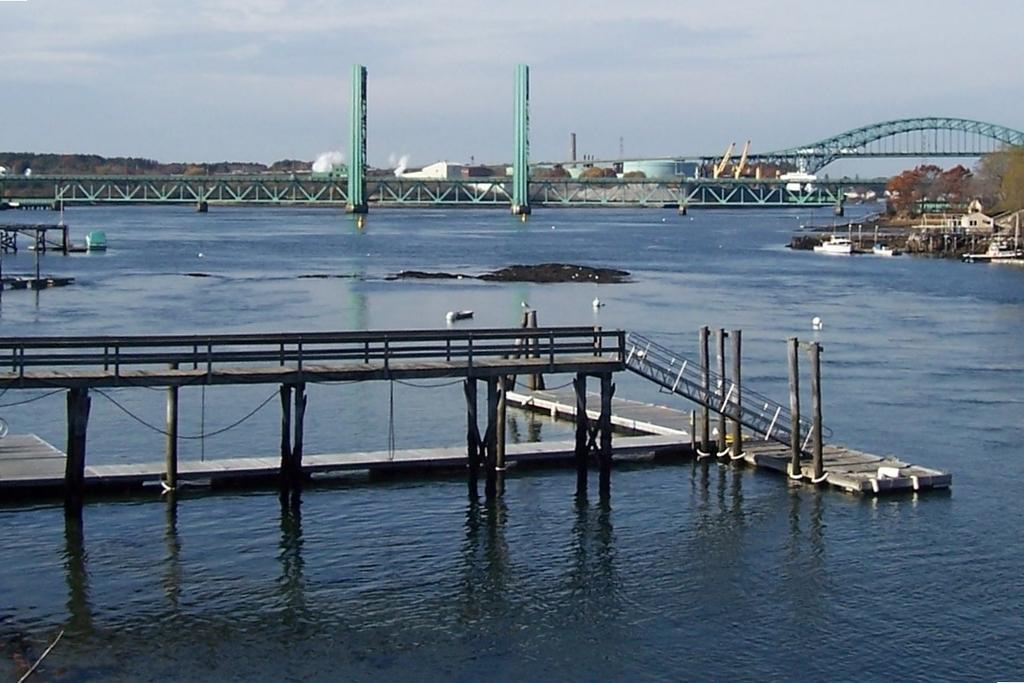How would you summarize this image in a sentence or two? In this picture I can see there is a bridge on the sea and there are some boats. In the backdrop there are buildings and there are trees. The sky is clear. 